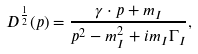<formula> <loc_0><loc_0><loc_500><loc_500>D ^ { \frac { 1 } { 2 } } ( p ) = \frac { \gamma \cdot p + m _ { I } } { p ^ { 2 } - m ^ { 2 } _ { I } + i m _ { I } \Gamma _ { I } } ,</formula> 